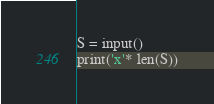Convert code to text. <code><loc_0><loc_0><loc_500><loc_500><_Python_>S = input()
print('x'* len(S))</code> 